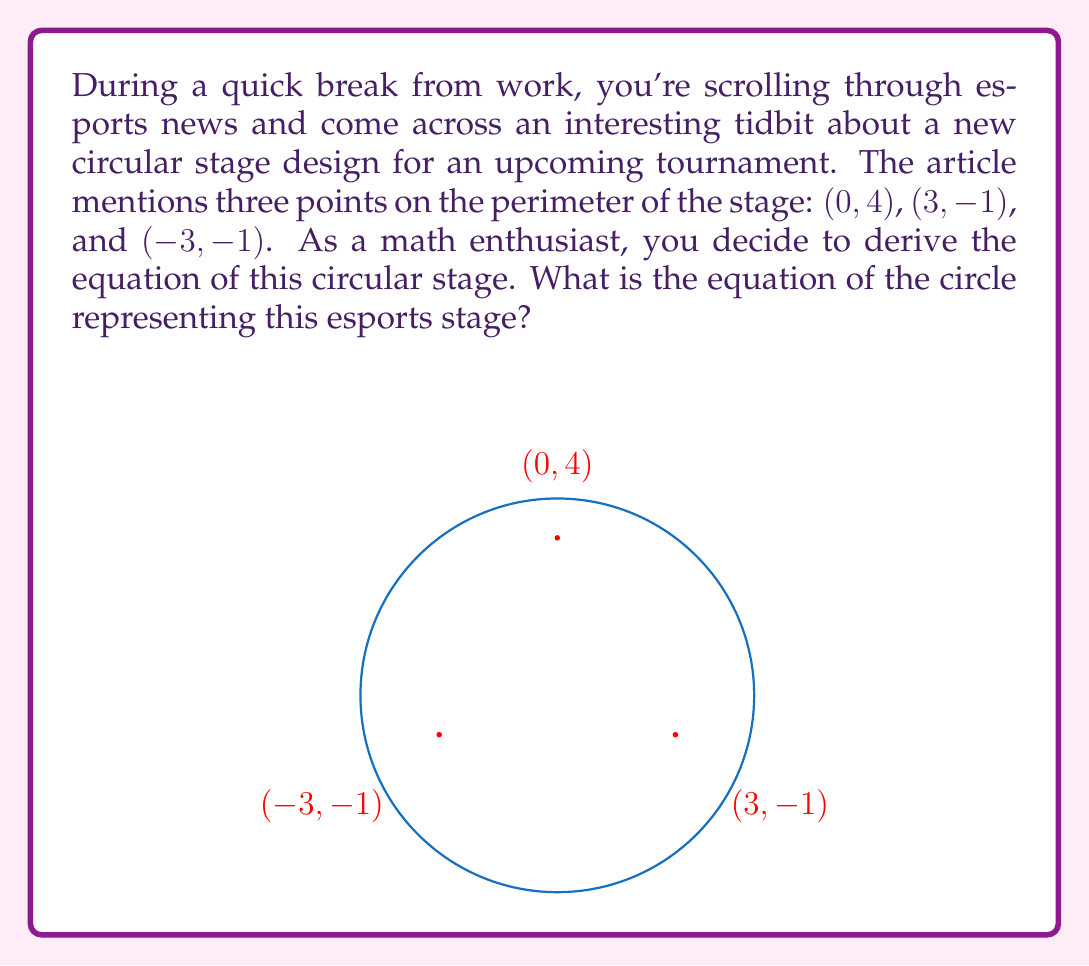Show me your answer to this math problem. Let's approach this step-by-step:

1) The general equation of a circle is $$(x-h)^2 + (y-k)^2 = r^2$$
   where (h,k) is the center and r is the radius.

2) To find the center and radius, we can use the perpendicular bisector method:
   
   a) Find the midpoint of two chords and their perpendicular bisectors.
   b) The intersection of these bisectors is the center.

3) Let's choose the chords formed by (0,4) to (3,-1) and (0,4) to (-3,-1):

   Midpoint of (0,4) and (3,-1): $(\frac{0+3}{2}, \frac{4+(-1)}{2}) = (\frac{3}{2}, \frac{3}{2})$
   Midpoint of (0,4) and (-3,-1): $(\frac{0+(-3)}{2}, \frac{4+(-1)}{2}) = (-\frac{3}{2}, \frac{3}{2})$

4) The slopes of these chords are:
   
   Slope of (0,4) to (3,-1): $m_1 = \frac{-1-4}{3-0} = -\frac{5}{3}$
   Slope of (0,4) to (-3,-1): $m_2 = \frac{-1-4}{-3-0} = \frac{5}{3}$

5) The perpendicular bisectors have slopes that are negative reciprocals:

   Slope of bisector 1: $\frac{3}{5}$
   Slope of bisector 2: $-\frac{3}{5}$

6) Using point-slope form, we can write equations for these bisectors:

   Bisector 1: $y - \frac{3}{2} = \frac{3}{5}(x - \frac{3}{2})$
   Bisector 2: $y - \frac{3}{2} = -\frac{3}{5}(x + \frac{3}{2})$

7) Solve these equations simultaneously to find the center:

   $y = \frac{3}{5}x + \frac{9}{10}$
   $y = -\frac{3}{5}x + \frac{9}{10}$

   Adding these equations:
   $2y = \frac{9}{5}$
   $y = \frac{9}{10}$

   Substituting back:
   $\frac{9}{10} = \frac{3}{5}x + \frac{9}{10}$
   $x = 0$

   So the center is (0, $\frac{9}{10}$)

8) To find the radius, we can use the distance formula from the center to any of the given points:

   $r^2 = (0-0)^2 + (4-\frac{9}{10})^2 = (\frac{31}{10})^2 = \frac{961}{100}$

9) Therefore, the equation of the circle is:

   $$(x-0)^2 + (y-\frac{9}{10})^2 = \frac{961}{100}$$
Answer: $x^2 + (y-\frac{9}{10})^2 = \frac{961}{100}$ 